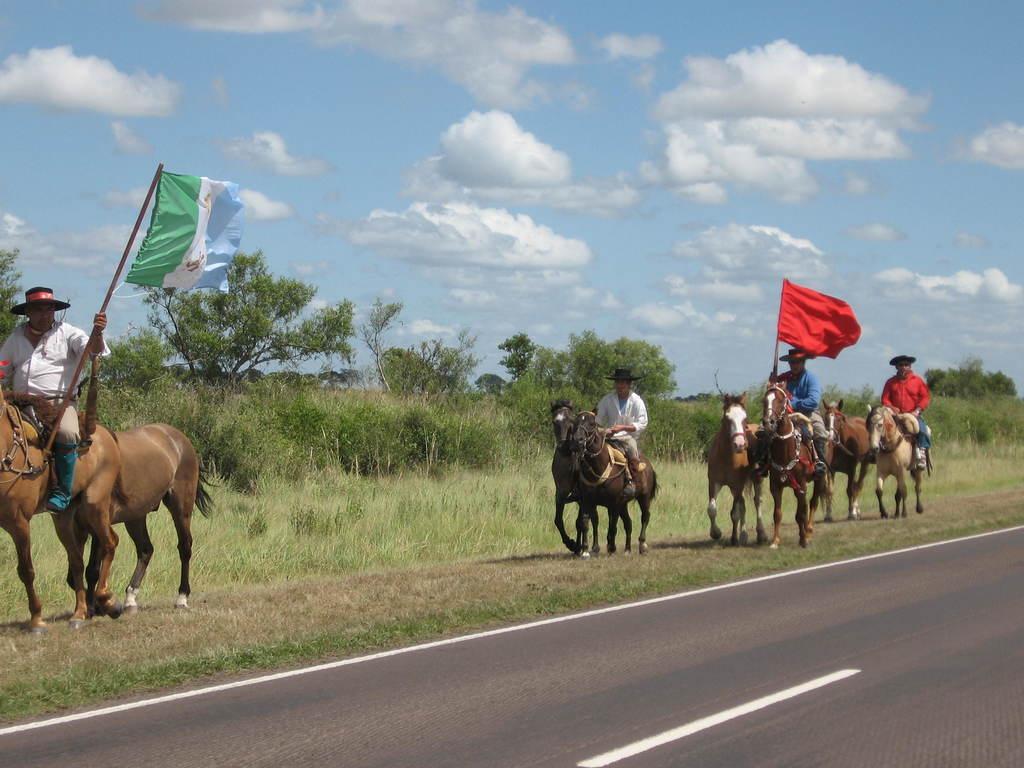Describe this image in one or two sentences. This picture shows few people riding horses and they wore hats on the heads and we see trees and grass on the ground and we see a cloudy sky and we see few horses with out riders moving along and we see a road on the side. 